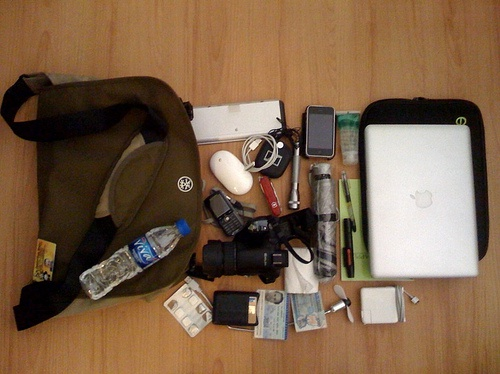Describe the objects in this image and their specific colors. I can see handbag in maroon, black, and gray tones, laptop in maroon, lightgray, darkgray, and gray tones, cell phone in maroon, lightgray, darkgray, and gray tones, bottle in maroon, gray, darkgray, and black tones, and cell phone in maroon, gray, black, and darkgray tones in this image. 